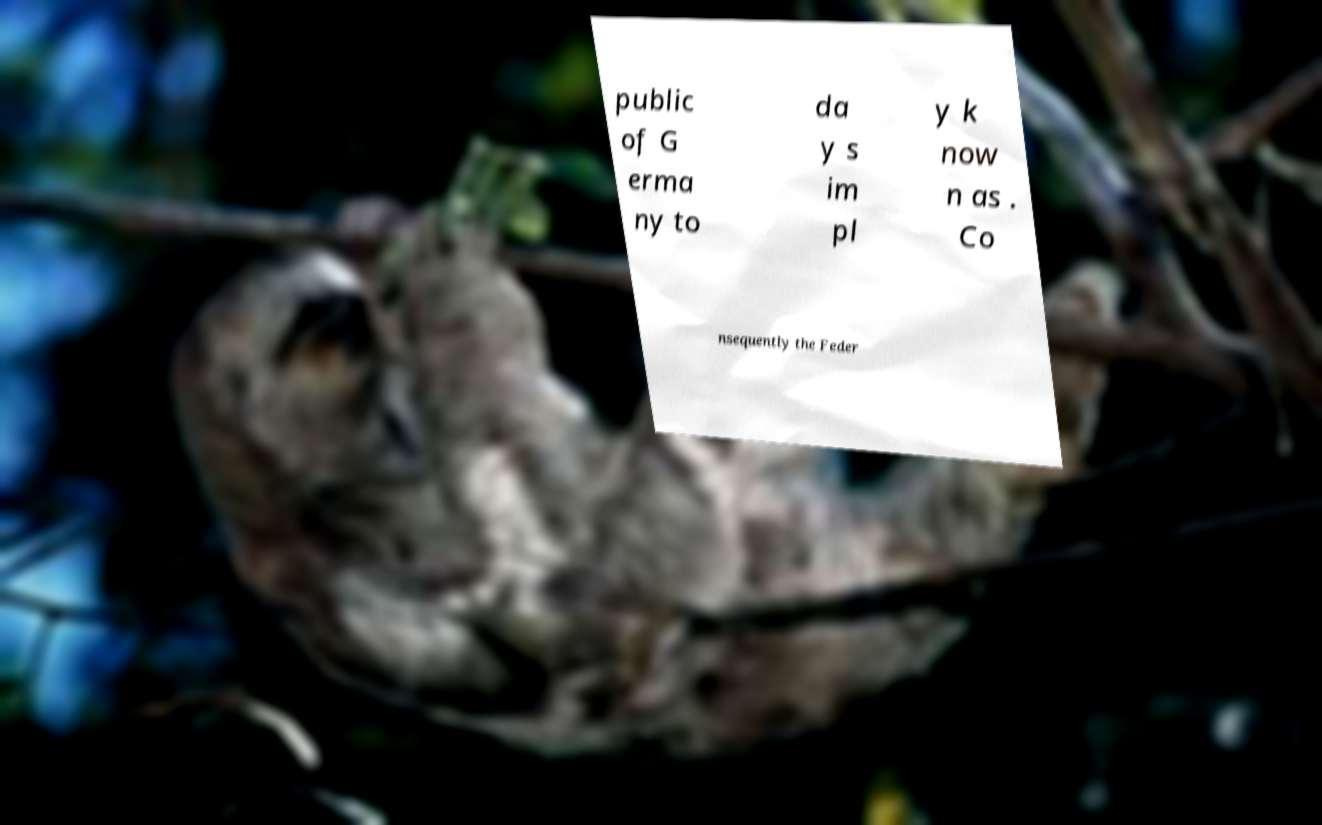Can you accurately transcribe the text from the provided image for me? public of G erma ny to da y s im pl y k now n as . Co nsequently the Feder 